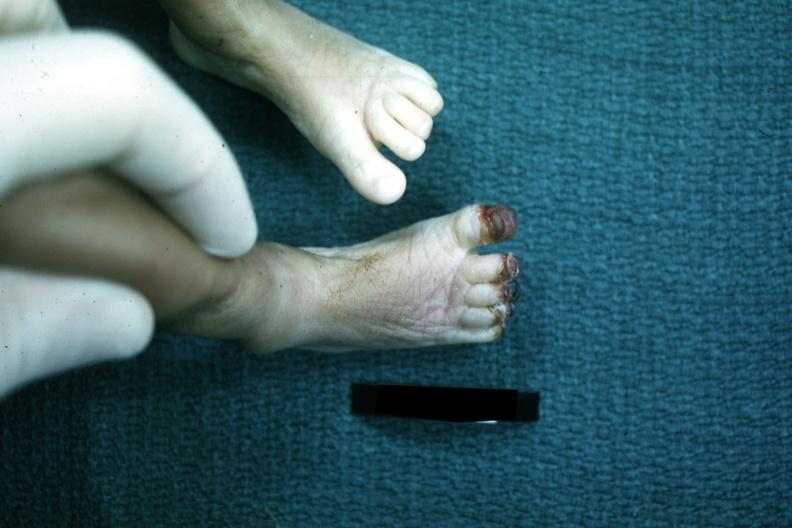re x-ray intramyocardial arteries present?
Answer the question using a single word or phrase. No 